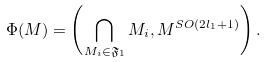<formula> <loc_0><loc_0><loc_500><loc_500>\Phi ( M ) = \left ( \bigcap _ { M _ { i } \in \mathfrak { F } _ { 1 } } M _ { i } , M ^ { S O ( 2 l _ { 1 } + 1 ) } \right ) .</formula> 